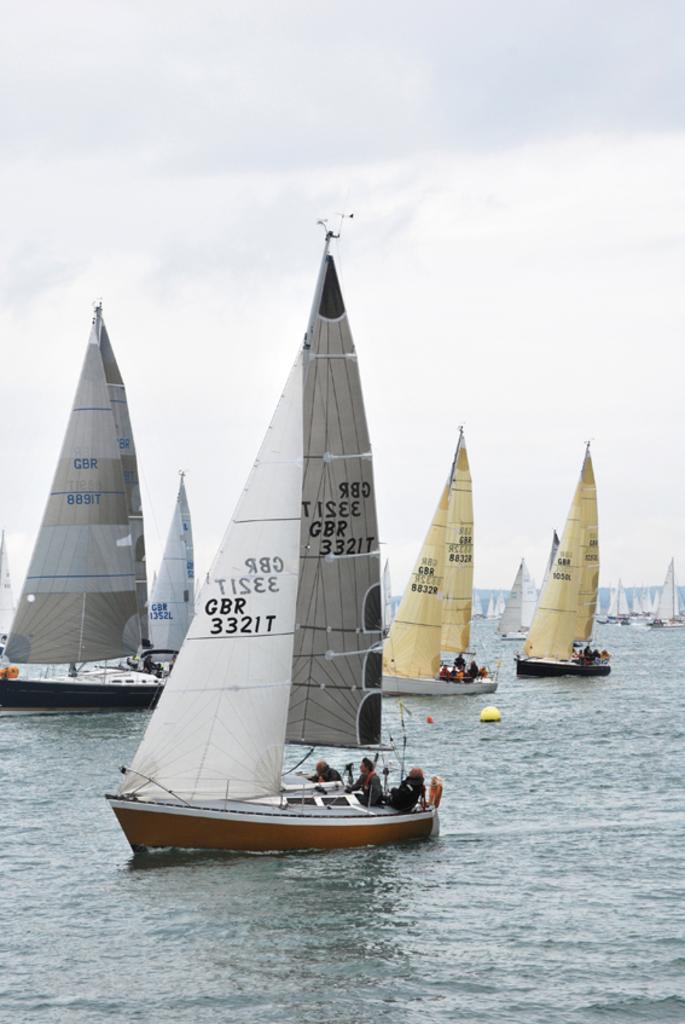What number is printed on the sail in the forefront?
Your answer should be very brief. 3321. How many yellow sails are in the picture?
Offer a very short reply. Answering does not require reading text in the image. 